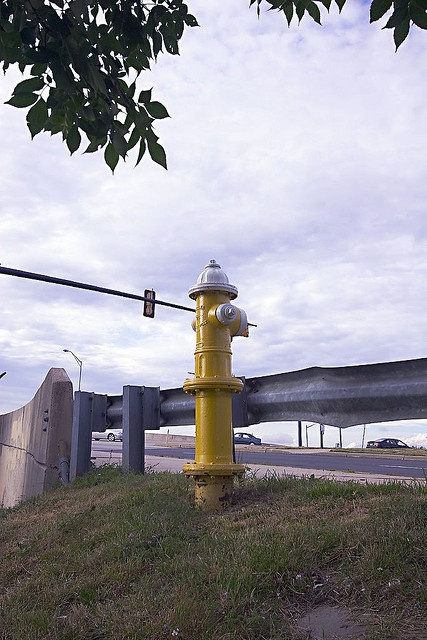Describe the objects in this image and their specific colors. I can see fire hydrant in black, olive, and gray tones, car in black, navy, gray, and lightgray tones, traffic light in black, gray, and navy tones, car in black, lavender, darkgray, and gray tones, and car in black, blue, navy, and purple tones in this image. 